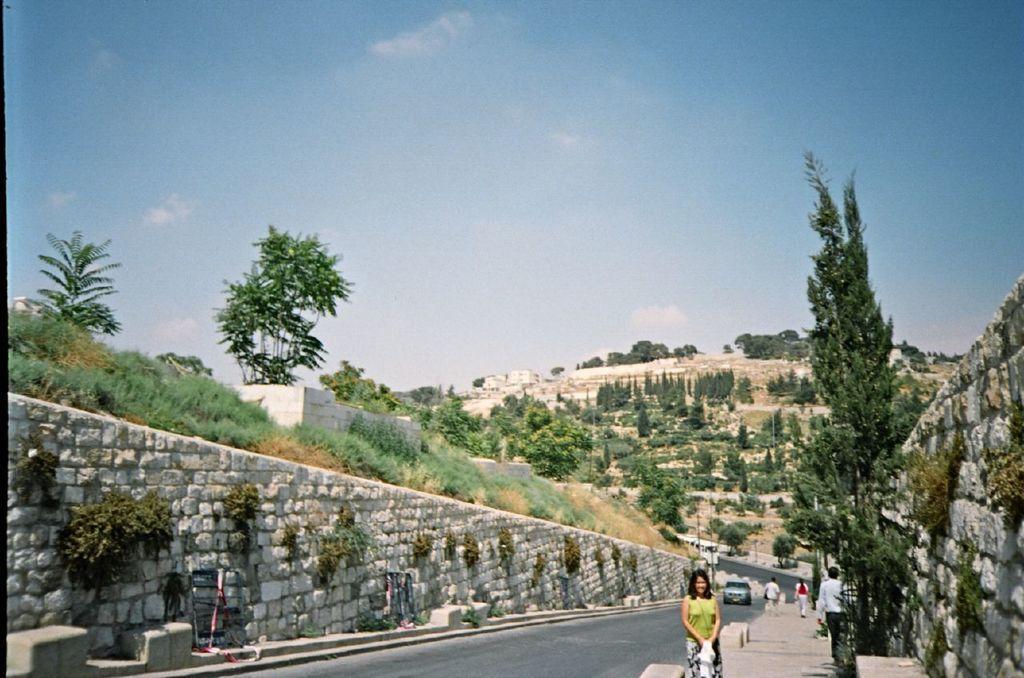In one or two sentences, can you explain what this image depicts? In this image I can see a road in the centre and on it I can see one vehicle. On the both side of the road I can see number of trees and on the right side of this image I can see few people are standing. On the left side I can see grass and in the background I can see clouds and the sky. 